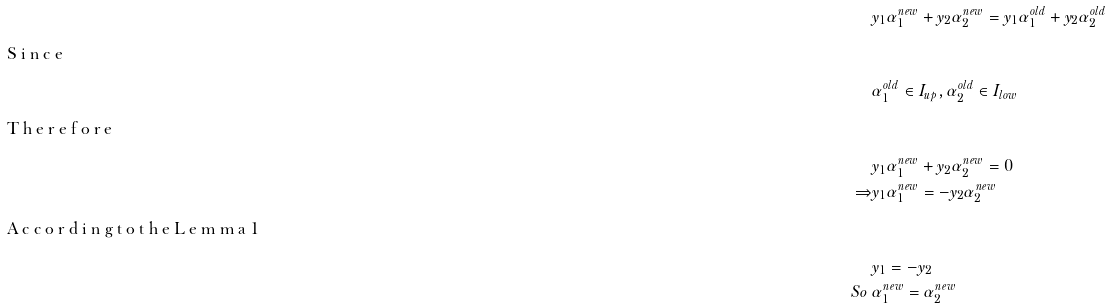Convert formula to latex. <formula><loc_0><loc_0><loc_500><loc_500>& y _ { 1 } \alpha _ { 1 } ^ { n e w } + y _ { 2 } \alpha _ { 2 } ^ { n e w } = y _ { 1 } \alpha _ { 1 } ^ { o l d } + y _ { 2 } \alpha _ { 2 } ^ { o l d } \\ \intertext { S i n c e } & \alpha _ { 1 } ^ { o l d } \in I _ { u p } , \alpha _ { 2 } ^ { o l d } \in I _ { l o w } \\ \intertext { T h e r e f o r e } & y _ { 1 } \alpha _ { 1 } ^ { n e w } + y _ { 2 } \alpha _ { 2 } ^ { n e w } = 0 \\ \Rightarrow & y _ { 1 } \alpha _ { 1 } ^ { n e w } = - y _ { 2 } \alpha _ { 2 } ^ { n e w } \\ \intertext { A c c o r d i n g t o t h e L e m m a 1 } & y _ { 1 } = - y _ { 2 } \\ S o \ & \alpha _ { 1 } ^ { n e w } = \alpha _ { 2 } ^ { n e w }</formula> 